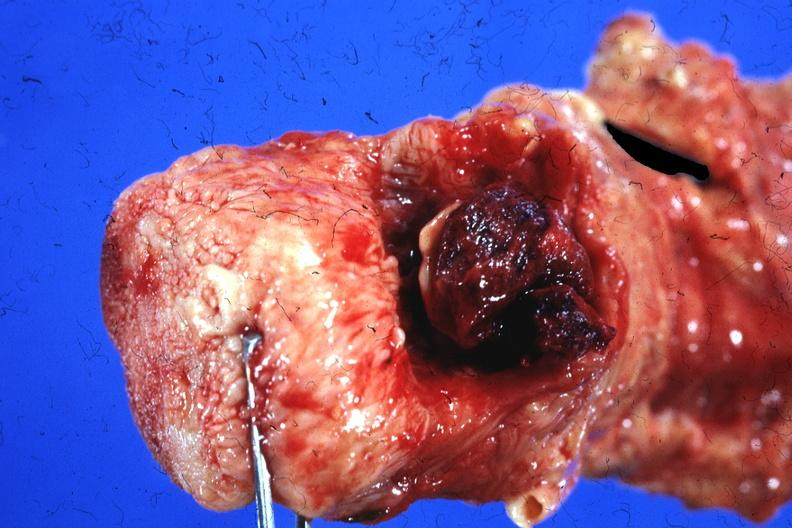how does this image show tongue and unopened larynx with blood clot over larynx chronic myeloproliferative disease?
Answer the question using a single word or phrase. Acute trans-formation bleeding disorder 